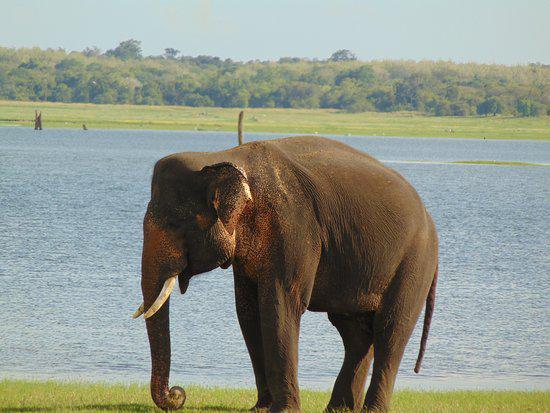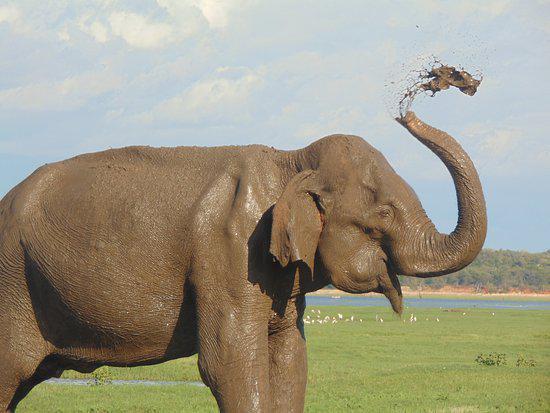The first image is the image on the left, the second image is the image on the right. Examine the images to the left and right. Is the description "An image shows at least ten elephants completely surrounded by water." accurate? Answer yes or no. No. The first image is the image on the left, the second image is the image on the right. Examine the images to the left and right. Is the description "Several elephants are in the water." accurate? Answer yes or no. No. 